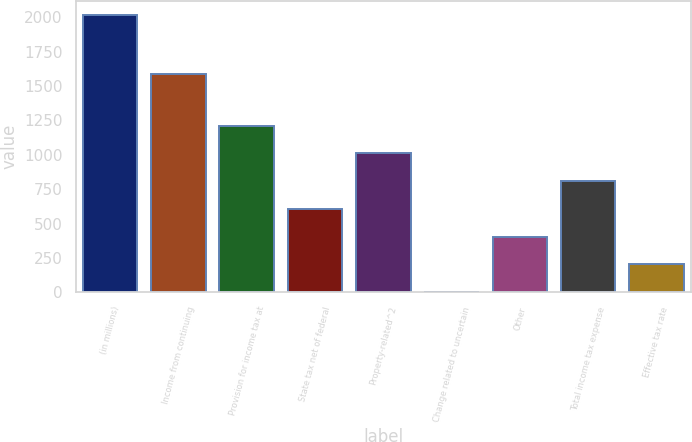<chart> <loc_0><loc_0><loc_500><loc_500><bar_chart><fcel>(in millions)<fcel>Income from continuing<fcel>Provision for income tax at<fcel>State tax net of federal<fcel>Property-related^2<fcel>Change related to uncertain<fcel>Other<fcel>Total income tax expense<fcel>Effective tax rate<nl><fcel>2016<fcel>1590<fcel>1211.2<fcel>607.6<fcel>1010<fcel>4<fcel>406.4<fcel>808.8<fcel>205.2<nl></chart> 